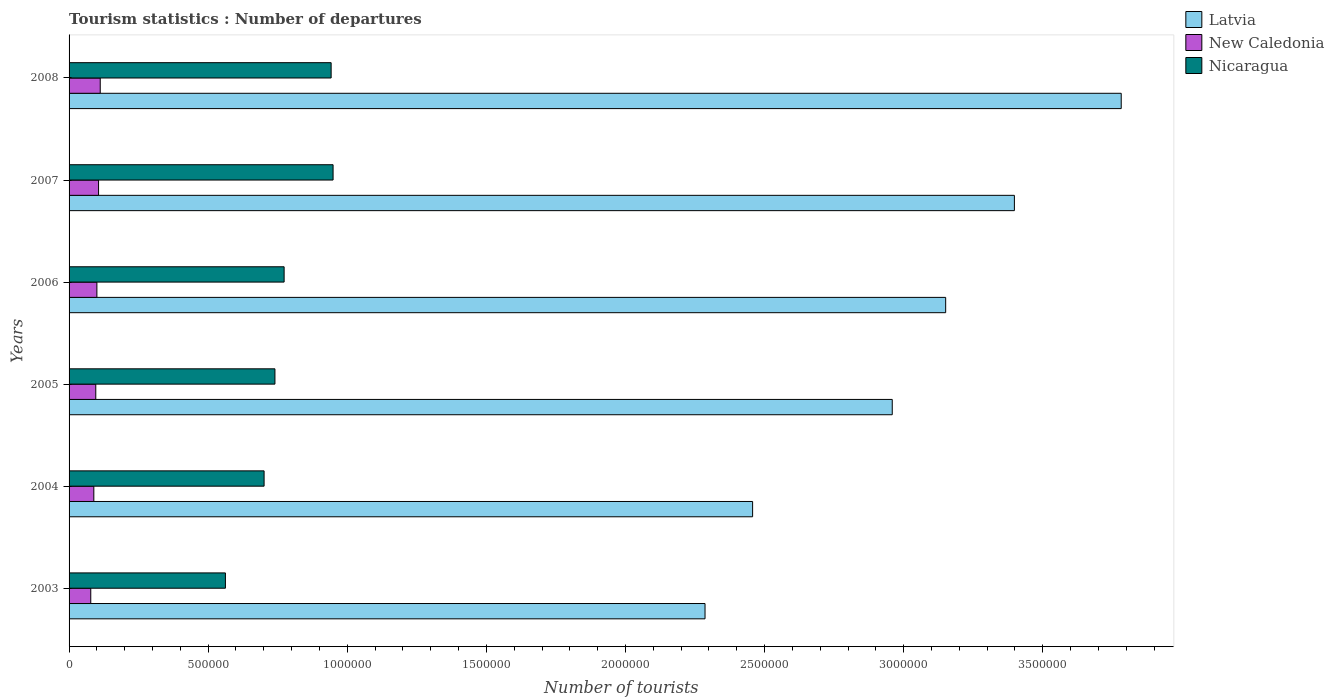How many different coloured bars are there?
Make the answer very short. 3. How many groups of bars are there?
Keep it short and to the point. 6. Are the number of bars per tick equal to the number of legend labels?
Your answer should be compact. Yes. How many bars are there on the 2nd tick from the bottom?
Keep it short and to the point. 3. What is the label of the 6th group of bars from the top?
Your answer should be compact. 2003. What is the number of tourist departures in Nicaragua in 2007?
Offer a terse response. 9.49e+05. Across all years, what is the maximum number of tourist departures in Latvia?
Offer a very short reply. 3.78e+06. Across all years, what is the minimum number of tourist departures in Nicaragua?
Keep it short and to the point. 5.62e+05. In which year was the number of tourist departures in Latvia maximum?
Your response must be concise. 2008. What is the total number of tourist departures in Nicaragua in the graph?
Provide a succinct answer. 4.67e+06. What is the difference between the number of tourist departures in Nicaragua in 2003 and that in 2005?
Offer a very short reply. -1.78e+05. What is the difference between the number of tourist departures in Latvia in 2005 and the number of tourist departures in New Caledonia in 2003?
Offer a very short reply. 2.88e+06. What is the average number of tourist departures in Latvia per year?
Your answer should be very brief. 3.01e+06. In the year 2005, what is the difference between the number of tourist departures in New Caledonia and number of tourist departures in Latvia?
Offer a terse response. -2.86e+06. In how many years, is the number of tourist departures in Nicaragua greater than 2400000 ?
Offer a very short reply. 0. What is the ratio of the number of tourist departures in Nicaragua in 2005 to that in 2007?
Your answer should be compact. 0.78. Is the number of tourist departures in Latvia in 2005 less than that in 2006?
Give a very brief answer. Yes. What is the difference between the highest and the second highest number of tourist departures in Latvia?
Your answer should be very brief. 3.84e+05. What is the difference between the highest and the lowest number of tourist departures in New Caledonia?
Offer a terse response. 3.40e+04. In how many years, is the number of tourist departures in New Caledonia greater than the average number of tourist departures in New Caledonia taken over all years?
Your response must be concise. 3. What does the 1st bar from the top in 2005 represents?
Make the answer very short. Nicaragua. What does the 2nd bar from the bottom in 2006 represents?
Give a very brief answer. New Caledonia. How many bars are there?
Offer a very short reply. 18. Are all the bars in the graph horizontal?
Offer a terse response. Yes. How many years are there in the graph?
Provide a short and direct response. 6. Does the graph contain any zero values?
Give a very brief answer. No. Where does the legend appear in the graph?
Provide a succinct answer. Top right. How are the legend labels stacked?
Provide a short and direct response. Vertical. What is the title of the graph?
Keep it short and to the point. Tourism statistics : Number of departures. What is the label or title of the X-axis?
Offer a very short reply. Number of tourists. What is the Number of tourists in Latvia in 2003?
Your answer should be compact. 2.29e+06. What is the Number of tourists of New Caledonia in 2003?
Offer a terse response. 7.80e+04. What is the Number of tourists of Nicaragua in 2003?
Keep it short and to the point. 5.62e+05. What is the Number of tourists of Latvia in 2004?
Provide a short and direct response. 2.46e+06. What is the Number of tourists of New Caledonia in 2004?
Your answer should be compact. 8.90e+04. What is the Number of tourists in Nicaragua in 2004?
Your answer should be very brief. 7.01e+05. What is the Number of tourists of Latvia in 2005?
Offer a terse response. 2.96e+06. What is the Number of tourists of New Caledonia in 2005?
Your answer should be compact. 9.60e+04. What is the Number of tourists of Nicaragua in 2005?
Your answer should be compact. 7.40e+05. What is the Number of tourists of Latvia in 2006?
Offer a terse response. 3.15e+06. What is the Number of tourists in New Caledonia in 2006?
Keep it short and to the point. 1.00e+05. What is the Number of tourists in Nicaragua in 2006?
Make the answer very short. 7.73e+05. What is the Number of tourists of Latvia in 2007?
Give a very brief answer. 3.40e+06. What is the Number of tourists in New Caledonia in 2007?
Provide a succinct answer. 1.06e+05. What is the Number of tourists of Nicaragua in 2007?
Provide a succinct answer. 9.49e+05. What is the Number of tourists of Latvia in 2008?
Make the answer very short. 3.78e+06. What is the Number of tourists of New Caledonia in 2008?
Make the answer very short. 1.12e+05. What is the Number of tourists of Nicaragua in 2008?
Provide a succinct answer. 9.42e+05. Across all years, what is the maximum Number of tourists of Latvia?
Offer a terse response. 3.78e+06. Across all years, what is the maximum Number of tourists in New Caledonia?
Provide a succinct answer. 1.12e+05. Across all years, what is the maximum Number of tourists of Nicaragua?
Ensure brevity in your answer.  9.49e+05. Across all years, what is the minimum Number of tourists in Latvia?
Your answer should be compact. 2.29e+06. Across all years, what is the minimum Number of tourists of New Caledonia?
Your answer should be very brief. 7.80e+04. Across all years, what is the minimum Number of tourists of Nicaragua?
Keep it short and to the point. 5.62e+05. What is the total Number of tourists of Latvia in the graph?
Give a very brief answer. 1.80e+07. What is the total Number of tourists of New Caledonia in the graph?
Your response must be concise. 5.81e+05. What is the total Number of tourists in Nicaragua in the graph?
Give a very brief answer. 4.67e+06. What is the difference between the Number of tourists in Latvia in 2003 and that in 2004?
Provide a succinct answer. -1.71e+05. What is the difference between the Number of tourists of New Caledonia in 2003 and that in 2004?
Give a very brief answer. -1.10e+04. What is the difference between the Number of tourists in Nicaragua in 2003 and that in 2004?
Offer a terse response. -1.39e+05. What is the difference between the Number of tourists in Latvia in 2003 and that in 2005?
Keep it short and to the point. -6.73e+05. What is the difference between the Number of tourists of New Caledonia in 2003 and that in 2005?
Keep it short and to the point. -1.80e+04. What is the difference between the Number of tourists in Nicaragua in 2003 and that in 2005?
Offer a terse response. -1.78e+05. What is the difference between the Number of tourists of Latvia in 2003 and that in 2006?
Offer a terse response. -8.65e+05. What is the difference between the Number of tourists of New Caledonia in 2003 and that in 2006?
Keep it short and to the point. -2.20e+04. What is the difference between the Number of tourists of Nicaragua in 2003 and that in 2006?
Offer a very short reply. -2.11e+05. What is the difference between the Number of tourists of Latvia in 2003 and that in 2007?
Offer a terse response. -1.11e+06. What is the difference between the Number of tourists of New Caledonia in 2003 and that in 2007?
Provide a succinct answer. -2.80e+04. What is the difference between the Number of tourists in Nicaragua in 2003 and that in 2007?
Provide a succinct answer. -3.87e+05. What is the difference between the Number of tourists in Latvia in 2003 and that in 2008?
Ensure brevity in your answer.  -1.50e+06. What is the difference between the Number of tourists of New Caledonia in 2003 and that in 2008?
Ensure brevity in your answer.  -3.40e+04. What is the difference between the Number of tourists of Nicaragua in 2003 and that in 2008?
Provide a succinct answer. -3.80e+05. What is the difference between the Number of tourists of Latvia in 2004 and that in 2005?
Make the answer very short. -5.02e+05. What is the difference between the Number of tourists of New Caledonia in 2004 and that in 2005?
Your answer should be compact. -7000. What is the difference between the Number of tourists in Nicaragua in 2004 and that in 2005?
Ensure brevity in your answer.  -3.90e+04. What is the difference between the Number of tourists of Latvia in 2004 and that in 2006?
Give a very brief answer. -6.94e+05. What is the difference between the Number of tourists in New Caledonia in 2004 and that in 2006?
Give a very brief answer. -1.10e+04. What is the difference between the Number of tourists of Nicaragua in 2004 and that in 2006?
Provide a succinct answer. -7.20e+04. What is the difference between the Number of tourists of Latvia in 2004 and that in 2007?
Keep it short and to the point. -9.41e+05. What is the difference between the Number of tourists of New Caledonia in 2004 and that in 2007?
Provide a succinct answer. -1.70e+04. What is the difference between the Number of tourists of Nicaragua in 2004 and that in 2007?
Your answer should be very brief. -2.48e+05. What is the difference between the Number of tourists of Latvia in 2004 and that in 2008?
Your answer should be very brief. -1.32e+06. What is the difference between the Number of tourists of New Caledonia in 2004 and that in 2008?
Ensure brevity in your answer.  -2.30e+04. What is the difference between the Number of tourists of Nicaragua in 2004 and that in 2008?
Provide a succinct answer. -2.41e+05. What is the difference between the Number of tourists in Latvia in 2005 and that in 2006?
Give a very brief answer. -1.92e+05. What is the difference between the Number of tourists of New Caledonia in 2005 and that in 2006?
Give a very brief answer. -4000. What is the difference between the Number of tourists of Nicaragua in 2005 and that in 2006?
Provide a short and direct response. -3.30e+04. What is the difference between the Number of tourists in Latvia in 2005 and that in 2007?
Ensure brevity in your answer.  -4.39e+05. What is the difference between the Number of tourists in Nicaragua in 2005 and that in 2007?
Make the answer very short. -2.09e+05. What is the difference between the Number of tourists of Latvia in 2005 and that in 2008?
Your response must be concise. -8.23e+05. What is the difference between the Number of tourists of New Caledonia in 2005 and that in 2008?
Your answer should be very brief. -1.60e+04. What is the difference between the Number of tourists in Nicaragua in 2005 and that in 2008?
Keep it short and to the point. -2.02e+05. What is the difference between the Number of tourists in Latvia in 2006 and that in 2007?
Offer a terse response. -2.47e+05. What is the difference between the Number of tourists in New Caledonia in 2006 and that in 2007?
Your response must be concise. -6000. What is the difference between the Number of tourists of Nicaragua in 2006 and that in 2007?
Provide a succinct answer. -1.76e+05. What is the difference between the Number of tourists of Latvia in 2006 and that in 2008?
Keep it short and to the point. -6.31e+05. What is the difference between the Number of tourists in New Caledonia in 2006 and that in 2008?
Give a very brief answer. -1.20e+04. What is the difference between the Number of tourists of Nicaragua in 2006 and that in 2008?
Offer a very short reply. -1.69e+05. What is the difference between the Number of tourists of Latvia in 2007 and that in 2008?
Your response must be concise. -3.84e+05. What is the difference between the Number of tourists in New Caledonia in 2007 and that in 2008?
Your answer should be compact. -6000. What is the difference between the Number of tourists in Nicaragua in 2007 and that in 2008?
Provide a succinct answer. 7000. What is the difference between the Number of tourists in Latvia in 2003 and the Number of tourists in New Caledonia in 2004?
Give a very brief answer. 2.20e+06. What is the difference between the Number of tourists in Latvia in 2003 and the Number of tourists in Nicaragua in 2004?
Ensure brevity in your answer.  1.58e+06. What is the difference between the Number of tourists in New Caledonia in 2003 and the Number of tourists in Nicaragua in 2004?
Provide a succinct answer. -6.23e+05. What is the difference between the Number of tourists in Latvia in 2003 and the Number of tourists in New Caledonia in 2005?
Your answer should be compact. 2.19e+06. What is the difference between the Number of tourists of Latvia in 2003 and the Number of tourists of Nicaragua in 2005?
Provide a succinct answer. 1.55e+06. What is the difference between the Number of tourists of New Caledonia in 2003 and the Number of tourists of Nicaragua in 2005?
Your response must be concise. -6.62e+05. What is the difference between the Number of tourists in Latvia in 2003 and the Number of tourists in New Caledonia in 2006?
Make the answer very short. 2.19e+06. What is the difference between the Number of tourists in Latvia in 2003 and the Number of tourists in Nicaragua in 2006?
Offer a terse response. 1.51e+06. What is the difference between the Number of tourists of New Caledonia in 2003 and the Number of tourists of Nicaragua in 2006?
Give a very brief answer. -6.95e+05. What is the difference between the Number of tourists in Latvia in 2003 and the Number of tourists in New Caledonia in 2007?
Your answer should be compact. 2.18e+06. What is the difference between the Number of tourists in Latvia in 2003 and the Number of tourists in Nicaragua in 2007?
Make the answer very short. 1.34e+06. What is the difference between the Number of tourists of New Caledonia in 2003 and the Number of tourists of Nicaragua in 2007?
Your answer should be compact. -8.71e+05. What is the difference between the Number of tourists of Latvia in 2003 and the Number of tourists of New Caledonia in 2008?
Your answer should be very brief. 2.17e+06. What is the difference between the Number of tourists of Latvia in 2003 and the Number of tourists of Nicaragua in 2008?
Offer a terse response. 1.34e+06. What is the difference between the Number of tourists in New Caledonia in 2003 and the Number of tourists in Nicaragua in 2008?
Offer a terse response. -8.64e+05. What is the difference between the Number of tourists of Latvia in 2004 and the Number of tourists of New Caledonia in 2005?
Provide a succinct answer. 2.36e+06. What is the difference between the Number of tourists of Latvia in 2004 and the Number of tourists of Nicaragua in 2005?
Keep it short and to the point. 1.72e+06. What is the difference between the Number of tourists of New Caledonia in 2004 and the Number of tourists of Nicaragua in 2005?
Give a very brief answer. -6.51e+05. What is the difference between the Number of tourists of Latvia in 2004 and the Number of tourists of New Caledonia in 2006?
Provide a succinct answer. 2.36e+06. What is the difference between the Number of tourists in Latvia in 2004 and the Number of tourists in Nicaragua in 2006?
Offer a terse response. 1.68e+06. What is the difference between the Number of tourists of New Caledonia in 2004 and the Number of tourists of Nicaragua in 2006?
Ensure brevity in your answer.  -6.84e+05. What is the difference between the Number of tourists in Latvia in 2004 and the Number of tourists in New Caledonia in 2007?
Keep it short and to the point. 2.35e+06. What is the difference between the Number of tourists of Latvia in 2004 and the Number of tourists of Nicaragua in 2007?
Give a very brief answer. 1.51e+06. What is the difference between the Number of tourists of New Caledonia in 2004 and the Number of tourists of Nicaragua in 2007?
Give a very brief answer. -8.60e+05. What is the difference between the Number of tourists of Latvia in 2004 and the Number of tourists of New Caledonia in 2008?
Provide a succinct answer. 2.34e+06. What is the difference between the Number of tourists of Latvia in 2004 and the Number of tourists of Nicaragua in 2008?
Provide a short and direct response. 1.52e+06. What is the difference between the Number of tourists of New Caledonia in 2004 and the Number of tourists of Nicaragua in 2008?
Ensure brevity in your answer.  -8.53e+05. What is the difference between the Number of tourists in Latvia in 2005 and the Number of tourists in New Caledonia in 2006?
Your answer should be very brief. 2.86e+06. What is the difference between the Number of tourists in Latvia in 2005 and the Number of tourists in Nicaragua in 2006?
Ensure brevity in your answer.  2.19e+06. What is the difference between the Number of tourists in New Caledonia in 2005 and the Number of tourists in Nicaragua in 2006?
Provide a short and direct response. -6.77e+05. What is the difference between the Number of tourists in Latvia in 2005 and the Number of tourists in New Caledonia in 2007?
Provide a short and direct response. 2.85e+06. What is the difference between the Number of tourists in Latvia in 2005 and the Number of tourists in Nicaragua in 2007?
Make the answer very short. 2.01e+06. What is the difference between the Number of tourists of New Caledonia in 2005 and the Number of tourists of Nicaragua in 2007?
Make the answer very short. -8.53e+05. What is the difference between the Number of tourists in Latvia in 2005 and the Number of tourists in New Caledonia in 2008?
Ensure brevity in your answer.  2.85e+06. What is the difference between the Number of tourists in Latvia in 2005 and the Number of tourists in Nicaragua in 2008?
Your response must be concise. 2.02e+06. What is the difference between the Number of tourists of New Caledonia in 2005 and the Number of tourists of Nicaragua in 2008?
Provide a short and direct response. -8.46e+05. What is the difference between the Number of tourists in Latvia in 2006 and the Number of tourists in New Caledonia in 2007?
Offer a very short reply. 3.04e+06. What is the difference between the Number of tourists in Latvia in 2006 and the Number of tourists in Nicaragua in 2007?
Keep it short and to the point. 2.20e+06. What is the difference between the Number of tourists of New Caledonia in 2006 and the Number of tourists of Nicaragua in 2007?
Offer a very short reply. -8.49e+05. What is the difference between the Number of tourists of Latvia in 2006 and the Number of tourists of New Caledonia in 2008?
Ensure brevity in your answer.  3.04e+06. What is the difference between the Number of tourists of Latvia in 2006 and the Number of tourists of Nicaragua in 2008?
Provide a succinct answer. 2.21e+06. What is the difference between the Number of tourists of New Caledonia in 2006 and the Number of tourists of Nicaragua in 2008?
Provide a succinct answer. -8.42e+05. What is the difference between the Number of tourists in Latvia in 2007 and the Number of tourists in New Caledonia in 2008?
Ensure brevity in your answer.  3.29e+06. What is the difference between the Number of tourists in Latvia in 2007 and the Number of tourists in Nicaragua in 2008?
Give a very brief answer. 2.46e+06. What is the difference between the Number of tourists of New Caledonia in 2007 and the Number of tourists of Nicaragua in 2008?
Your answer should be very brief. -8.36e+05. What is the average Number of tourists in Latvia per year?
Offer a terse response. 3.01e+06. What is the average Number of tourists of New Caledonia per year?
Your answer should be very brief. 9.68e+04. What is the average Number of tourists in Nicaragua per year?
Provide a succinct answer. 7.78e+05. In the year 2003, what is the difference between the Number of tourists in Latvia and Number of tourists in New Caledonia?
Provide a short and direct response. 2.21e+06. In the year 2003, what is the difference between the Number of tourists of Latvia and Number of tourists of Nicaragua?
Your answer should be compact. 1.72e+06. In the year 2003, what is the difference between the Number of tourists of New Caledonia and Number of tourists of Nicaragua?
Your answer should be compact. -4.84e+05. In the year 2004, what is the difference between the Number of tourists of Latvia and Number of tourists of New Caledonia?
Offer a terse response. 2.37e+06. In the year 2004, what is the difference between the Number of tourists of Latvia and Number of tourists of Nicaragua?
Your answer should be compact. 1.76e+06. In the year 2004, what is the difference between the Number of tourists in New Caledonia and Number of tourists in Nicaragua?
Offer a terse response. -6.12e+05. In the year 2005, what is the difference between the Number of tourists of Latvia and Number of tourists of New Caledonia?
Your answer should be very brief. 2.86e+06. In the year 2005, what is the difference between the Number of tourists in Latvia and Number of tourists in Nicaragua?
Your answer should be compact. 2.22e+06. In the year 2005, what is the difference between the Number of tourists of New Caledonia and Number of tourists of Nicaragua?
Your response must be concise. -6.44e+05. In the year 2006, what is the difference between the Number of tourists of Latvia and Number of tourists of New Caledonia?
Your answer should be compact. 3.05e+06. In the year 2006, what is the difference between the Number of tourists in Latvia and Number of tourists in Nicaragua?
Give a very brief answer. 2.38e+06. In the year 2006, what is the difference between the Number of tourists in New Caledonia and Number of tourists in Nicaragua?
Ensure brevity in your answer.  -6.73e+05. In the year 2007, what is the difference between the Number of tourists in Latvia and Number of tourists in New Caledonia?
Ensure brevity in your answer.  3.29e+06. In the year 2007, what is the difference between the Number of tourists of Latvia and Number of tourists of Nicaragua?
Your answer should be compact. 2.45e+06. In the year 2007, what is the difference between the Number of tourists of New Caledonia and Number of tourists of Nicaragua?
Your response must be concise. -8.43e+05. In the year 2008, what is the difference between the Number of tourists of Latvia and Number of tourists of New Caledonia?
Provide a short and direct response. 3.67e+06. In the year 2008, what is the difference between the Number of tourists of Latvia and Number of tourists of Nicaragua?
Keep it short and to the point. 2.84e+06. In the year 2008, what is the difference between the Number of tourists in New Caledonia and Number of tourists in Nicaragua?
Make the answer very short. -8.30e+05. What is the ratio of the Number of tourists in Latvia in 2003 to that in 2004?
Offer a very short reply. 0.93. What is the ratio of the Number of tourists of New Caledonia in 2003 to that in 2004?
Make the answer very short. 0.88. What is the ratio of the Number of tourists of Nicaragua in 2003 to that in 2004?
Provide a short and direct response. 0.8. What is the ratio of the Number of tourists of Latvia in 2003 to that in 2005?
Your response must be concise. 0.77. What is the ratio of the Number of tourists of New Caledonia in 2003 to that in 2005?
Provide a short and direct response. 0.81. What is the ratio of the Number of tourists in Nicaragua in 2003 to that in 2005?
Your answer should be compact. 0.76. What is the ratio of the Number of tourists of Latvia in 2003 to that in 2006?
Give a very brief answer. 0.73. What is the ratio of the Number of tourists in New Caledonia in 2003 to that in 2006?
Provide a succinct answer. 0.78. What is the ratio of the Number of tourists in Nicaragua in 2003 to that in 2006?
Keep it short and to the point. 0.73. What is the ratio of the Number of tourists of Latvia in 2003 to that in 2007?
Your answer should be compact. 0.67. What is the ratio of the Number of tourists of New Caledonia in 2003 to that in 2007?
Offer a terse response. 0.74. What is the ratio of the Number of tourists of Nicaragua in 2003 to that in 2007?
Offer a very short reply. 0.59. What is the ratio of the Number of tourists in Latvia in 2003 to that in 2008?
Offer a very short reply. 0.6. What is the ratio of the Number of tourists in New Caledonia in 2003 to that in 2008?
Provide a short and direct response. 0.7. What is the ratio of the Number of tourists in Nicaragua in 2003 to that in 2008?
Offer a terse response. 0.6. What is the ratio of the Number of tourists of Latvia in 2004 to that in 2005?
Your answer should be compact. 0.83. What is the ratio of the Number of tourists in New Caledonia in 2004 to that in 2005?
Make the answer very short. 0.93. What is the ratio of the Number of tourists of Nicaragua in 2004 to that in 2005?
Offer a very short reply. 0.95. What is the ratio of the Number of tourists in Latvia in 2004 to that in 2006?
Give a very brief answer. 0.78. What is the ratio of the Number of tourists of New Caledonia in 2004 to that in 2006?
Make the answer very short. 0.89. What is the ratio of the Number of tourists in Nicaragua in 2004 to that in 2006?
Offer a terse response. 0.91. What is the ratio of the Number of tourists in Latvia in 2004 to that in 2007?
Offer a terse response. 0.72. What is the ratio of the Number of tourists of New Caledonia in 2004 to that in 2007?
Keep it short and to the point. 0.84. What is the ratio of the Number of tourists of Nicaragua in 2004 to that in 2007?
Keep it short and to the point. 0.74. What is the ratio of the Number of tourists in Latvia in 2004 to that in 2008?
Offer a very short reply. 0.65. What is the ratio of the Number of tourists in New Caledonia in 2004 to that in 2008?
Your answer should be very brief. 0.79. What is the ratio of the Number of tourists in Nicaragua in 2004 to that in 2008?
Your answer should be very brief. 0.74. What is the ratio of the Number of tourists of Latvia in 2005 to that in 2006?
Provide a short and direct response. 0.94. What is the ratio of the Number of tourists of Nicaragua in 2005 to that in 2006?
Your response must be concise. 0.96. What is the ratio of the Number of tourists of Latvia in 2005 to that in 2007?
Your answer should be very brief. 0.87. What is the ratio of the Number of tourists of New Caledonia in 2005 to that in 2007?
Offer a very short reply. 0.91. What is the ratio of the Number of tourists of Nicaragua in 2005 to that in 2007?
Provide a short and direct response. 0.78. What is the ratio of the Number of tourists in Latvia in 2005 to that in 2008?
Your answer should be very brief. 0.78. What is the ratio of the Number of tourists of Nicaragua in 2005 to that in 2008?
Your answer should be compact. 0.79. What is the ratio of the Number of tourists of Latvia in 2006 to that in 2007?
Your answer should be compact. 0.93. What is the ratio of the Number of tourists in New Caledonia in 2006 to that in 2007?
Your answer should be compact. 0.94. What is the ratio of the Number of tourists in Nicaragua in 2006 to that in 2007?
Your answer should be compact. 0.81. What is the ratio of the Number of tourists of Latvia in 2006 to that in 2008?
Your answer should be compact. 0.83. What is the ratio of the Number of tourists in New Caledonia in 2006 to that in 2008?
Offer a terse response. 0.89. What is the ratio of the Number of tourists of Nicaragua in 2006 to that in 2008?
Keep it short and to the point. 0.82. What is the ratio of the Number of tourists in Latvia in 2007 to that in 2008?
Offer a very short reply. 0.9. What is the ratio of the Number of tourists of New Caledonia in 2007 to that in 2008?
Ensure brevity in your answer.  0.95. What is the ratio of the Number of tourists in Nicaragua in 2007 to that in 2008?
Provide a succinct answer. 1.01. What is the difference between the highest and the second highest Number of tourists of Latvia?
Offer a very short reply. 3.84e+05. What is the difference between the highest and the second highest Number of tourists of New Caledonia?
Offer a very short reply. 6000. What is the difference between the highest and the second highest Number of tourists in Nicaragua?
Offer a terse response. 7000. What is the difference between the highest and the lowest Number of tourists of Latvia?
Your response must be concise. 1.50e+06. What is the difference between the highest and the lowest Number of tourists in New Caledonia?
Provide a succinct answer. 3.40e+04. What is the difference between the highest and the lowest Number of tourists in Nicaragua?
Keep it short and to the point. 3.87e+05. 